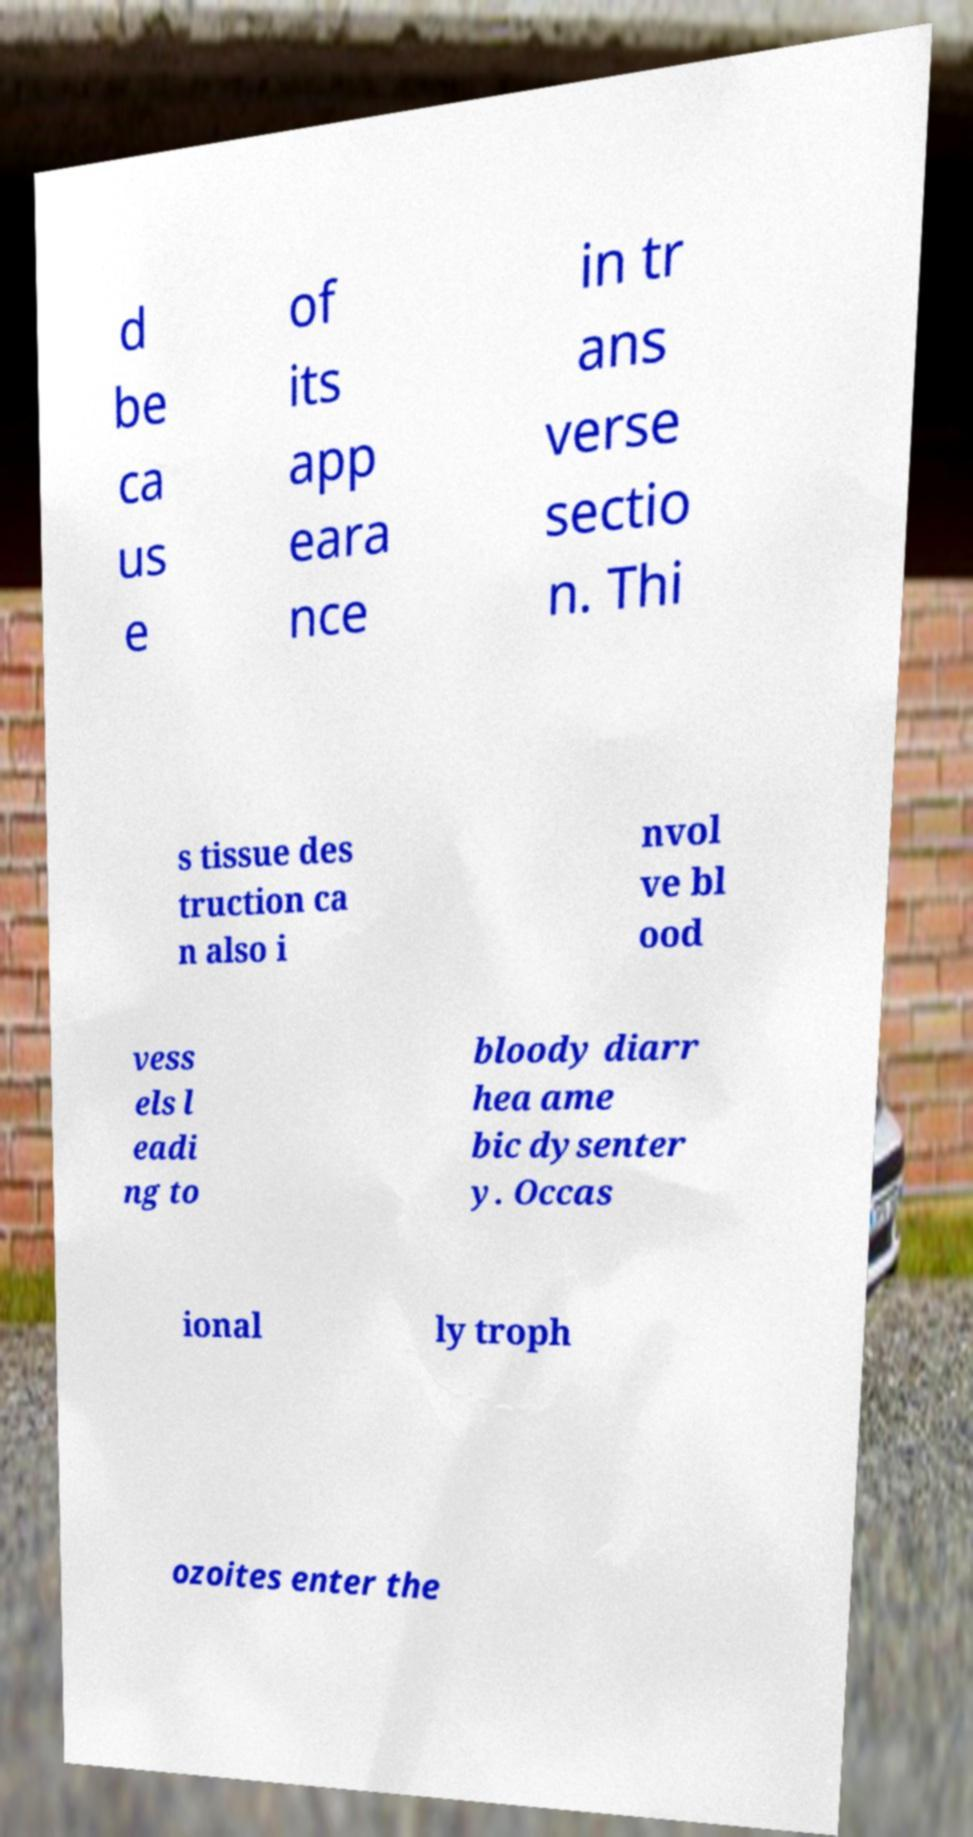Please read and relay the text visible in this image. What does it say? d be ca us e of its app eara nce in tr ans verse sectio n. Thi s tissue des truction ca n also i nvol ve bl ood vess els l eadi ng to bloody diarr hea ame bic dysenter y. Occas ional ly troph ozoites enter the 